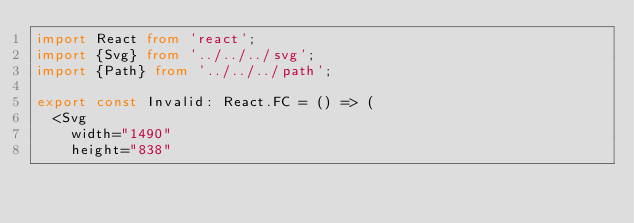<code> <loc_0><loc_0><loc_500><loc_500><_TypeScript_>import React from 'react';
import {Svg} from '../../../svg';
import {Path} from '../../../path';

export const Invalid: React.FC = () => (
  <Svg
    width="1490"
    height="838"</code> 